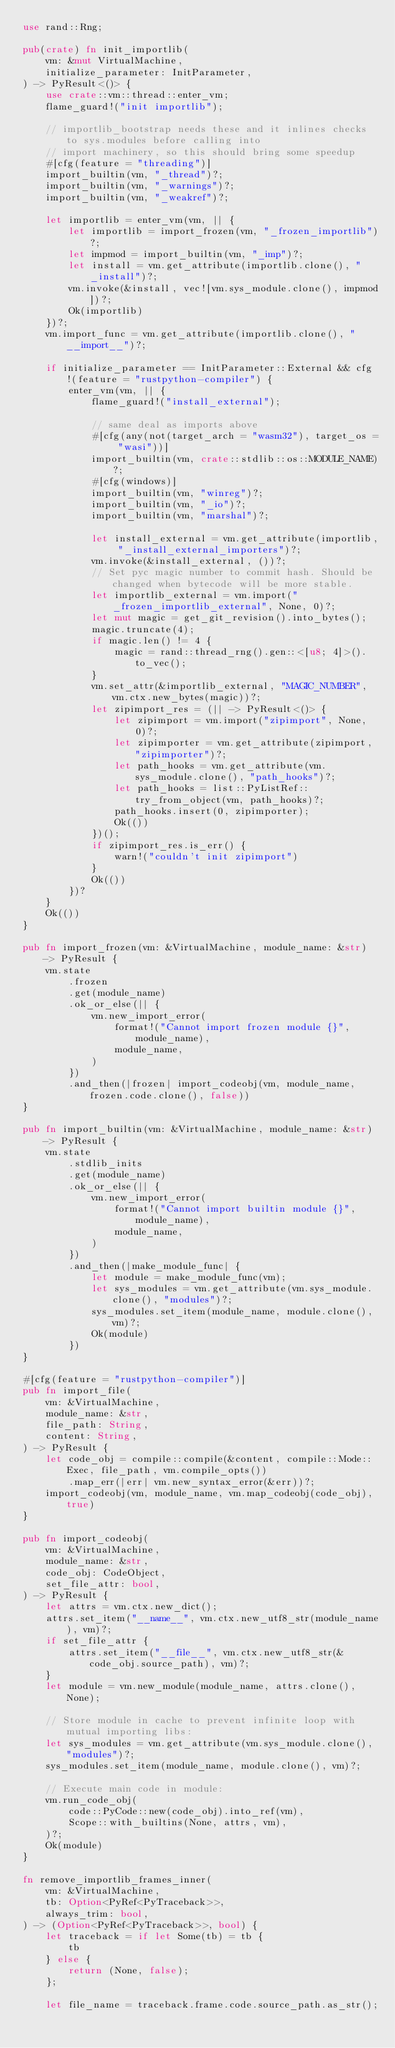Convert code to text. <code><loc_0><loc_0><loc_500><loc_500><_Rust_>use rand::Rng;

pub(crate) fn init_importlib(
    vm: &mut VirtualMachine,
    initialize_parameter: InitParameter,
) -> PyResult<()> {
    use crate::vm::thread::enter_vm;
    flame_guard!("init importlib");

    // importlib_bootstrap needs these and it inlines checks to sys.modules before calling into
    // import machinery, so this should bring some speedup
    #[cfg(feature = "threading")]
    import_builtin(vm, "_thread")?;
    import_builtin(vm, "_warnings")?;
    import_builtin(vm, "_weakref")?;

    let importlib = enter_vm(vm, || {
        let importlib = import_frozen(vm, "_frozen_importlib")?;
        let impmod = import_builtin(vm, "_imp")?;
        let install = vm.get_attribute(importlib.clone(), "_install")?;
        vm.invoke(&install, vec![vm.sys_module.clone(), impmod])?;
        Ok(importlib)
    })?;
    vm.import_func = vm.get_attribute(importlib.clone(), "__import__")?;

    if initialize_parameter == InitParameter::External && cfg!(feature = "rustpython-compiler") {
        enter_vm(vm, || {
            flame_guard!("install_external");

            // same deal as imports above
            #[cfg(any(not(target_arch = "wasm32"), target_os = "wasi"))]
            import_builtin(vm, crate::stdlib::os::MODULE_NAME)?;
            #[cfg(windows)]
            import_builtin(vm, "winreg")?;
            import_builtin(vm, "_io")?;
            import_builtin(vm, "marshal")?;

            let install_external = vm.get_attribute(importlib, "_install_external_importers")?;
            vm.invoke(&install_external, ())?;
            // Set pyc magic number to commit hash. Should be changed when bytecode will be more stable.
            let importlib_external = vm.import("_frozen_importlib_external", None, 0)?;
            let mut magic = get_git_revision().into_bytes();
            magic.truncate(4);
            if magic.len() != 4 {
                magic = rand::thread_rng().gen::<[u8; 4]>().to_vec();
            }
            vm.set_attr(&importlib_external, "MAGIC_NUMBER", vm.ctx.new_bytes(magic))?;
            let zipimport_res = (|| -> PyResult<()> {
                let zipimport = vm.import("zipimport", None, 0)?;
                let zipimporter = vm.get_attribute(zipimport, "zipimporter")?;
                let path_hooks = vm.get_attribute(vm.sys_module.clone(), "path_hooks")?;
                let path_hooks = list::PyListRef::try_from_object(vm, path_hooks)?;
                path_hooks.insert(0, zipimporter);
                Ok(())
            })();
            if zipimport_res.is_err() {
                warn!("couldn't init zipimport")
            }
            Ok(())
        })?
    }
    Ok(())
}

pub fn import_frozen(vm: &VirtualMachine, module_name: &str) -> PyResult {
    vm.state
        .frozen
        .get(module_name)
        .ok_or_else(|| {
            vm.new_import_error(
                format!("Cannot import frozen module {}", module_name),
                module_name,
            )
        })
        .and_then(|frozen| import_codeobj(vm, module_name, frozen.code.clone(), false))
}

pub fn import_builtin(vm: &VirtualMachine, module_name: &str) -> PyResult {
    vm.state
        .stdlib_inits
        .get(module_name)
        .ok_or_else(|| {
            vm.new_import_error(
                format!("Cannot import builtin module {}", module_name),
                module_name,
            )
        })
        .and_then(|make_module_func| {
            let module = make_module_func(vm);
            let sys_modules = vm.get_attribute(vm.sys_module.clone(), "modules")?;
            sys_modules.set_item(module_name, module.clone(), vm)?;
            Ok(module)
        })
}

#[cfg(feature = "rustpython-compiler")]
pub fn import_file(
    vm: &VirtualMachine,
    module_name: &str,
    file_path: String,
    content: String,
) -> PyResult {
    let code_obj = compile::compile(&content, compile::Mode::Exec, file_path, vm.compile_opts())
        .map_err(|err| vm.new_syntax_error(&err))?;
    import_codeobj(vm, module_name, vm.map_codeobj(code_obj), true)
}

pub fn import_codeobj(
    vm: &VirtualMachine,
    module_name: &str,
    code_obj: CodeObject,
    set_file_attr: bool,
) -> PyResult {
    let attrs = vm.ctx.new_dict();
    attrs.set_item("__name__", vm.ctx.new_utf8_str(module_name), vm)?;
    if set_file_attr {
        attrs.set_item("__file__", vm.ctx.new_utf8_str(&code_obj.source_path), vm)?;
    }
    let module = vm.new_module(module_name, attrs.clone(), None);

    // Store module in cache to prevent infinite loop with mutual importing libs:
    let sys_modules = vm.get_attribute(vm.sys_module.clone(), "modules")?;
    sys_modules.set_item(module_name, module.clone(), vm)?;

    // Execute main code in module:
    vm.run_code_obj(
        code::PyCode::new(code_obj).into_ref(vm),
        Scope::with_builtins(None, attrs, vm),
    )?;
    Ok(module)
}

fn remove_importlib_frames_inner(
    vm: &VirtualMachine,
    tb: Option<PyRef<PyTraceback>>,
    always_trim: bool,
) -> (Option<PyRef<PyTraceback>>, bool) {
    let traceback = if let Some(tb) = tb {
        tb
    } else {
        return (None, false);
    };

    let file_name = traceback.frame.code.source_path.as_str();
</code> 